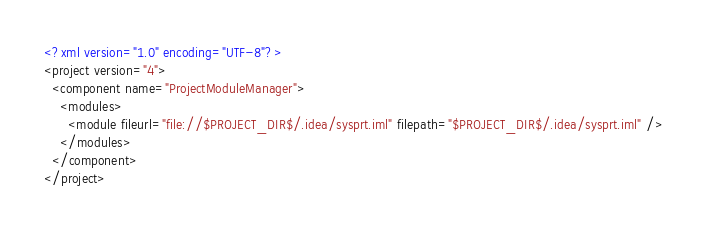<code> <loc_0><loc_0><loc_500><loc_500><_XML_><?xml version="1.0" encoding="UTF-8"?>
<project version="4">
  <component name="ProjectModuleManager">
    <modules>
      <module fileurl="file://$PROJECT_DIR$/.idea/sysprt.iml" filepath="$PROJECT_DIR$/.idea/sysprt.iml" />
    </modules>
  </component>
</project></code> 